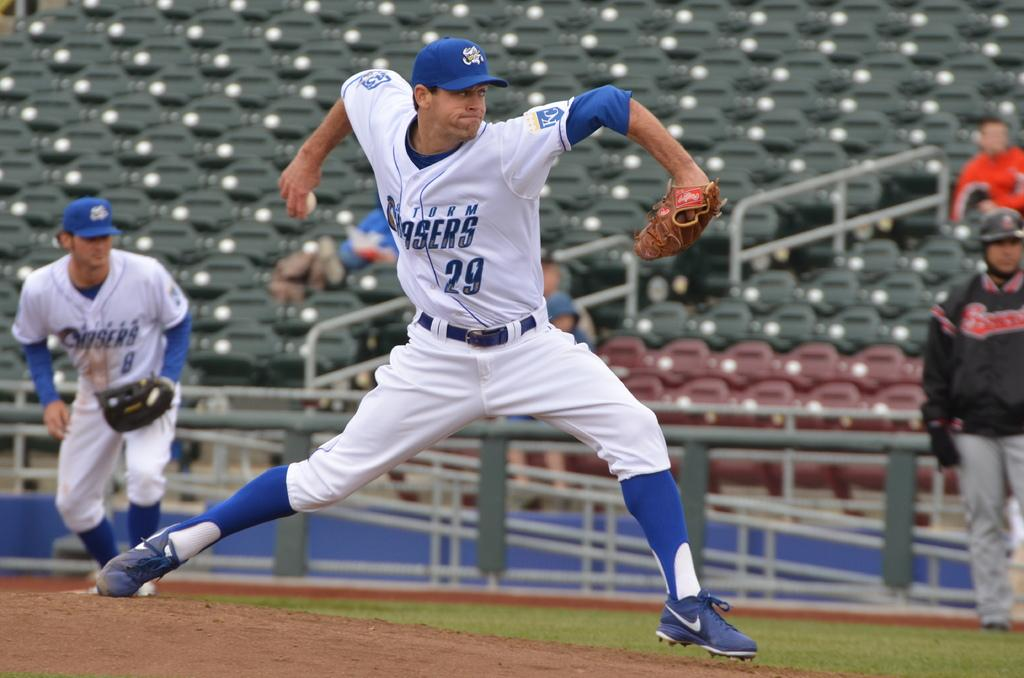<image>
Relay a brief, clear account of the picture shown. A baseballplayer wearing white and the number 29 is about to throw the ball at a fast rate. 